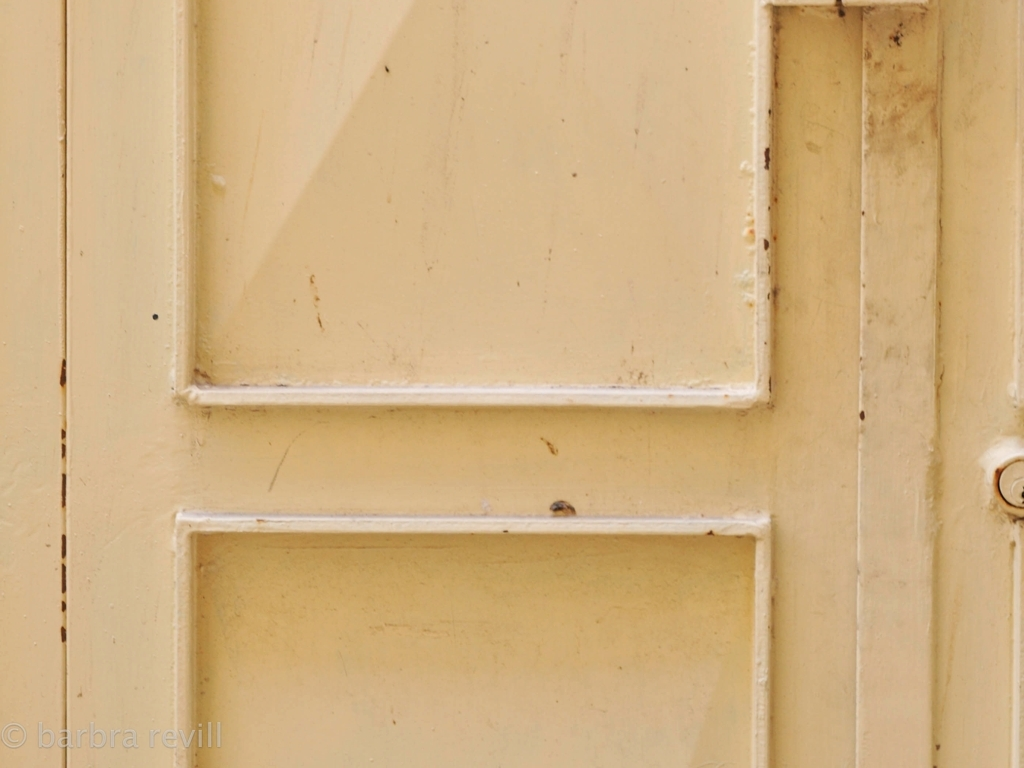Are there any quality issues with this image? Yes, the image appears to have some focus issues, as certain areas are not as sharp as they could be. There is evident wear and discoloration on the door, with scratches and dirt spots that could be considered as lacking in aesthetic quality. Lighting seems flat, and there's a lack of contrast which makes the image look somewhat dull. 